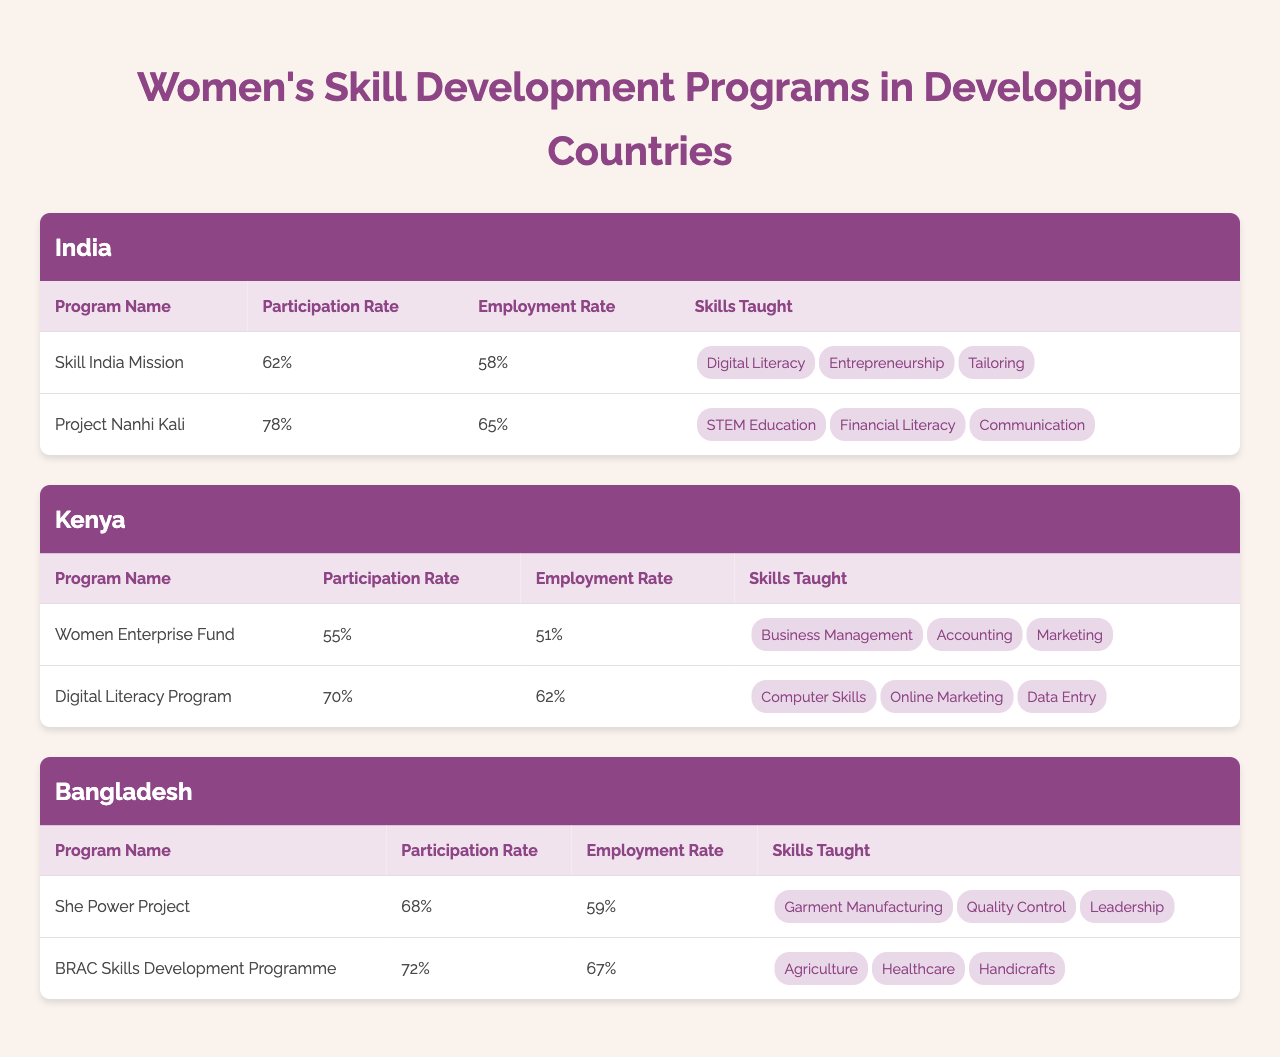What is the participation rate for the "She Power Project" in Bangladesh? The table indicates that the participation rate for the "She Power Project" in Bangladesh is listed under its respective section, which shows "68%".
Answer: 68% Which country has the highest employment rate among the programs listed? To find the highest employment rate, I compare the employment rates across all programs: India's "Project Nanhi Kali" is 65%, Bangladesh's "BRAC Skills Development Programme" is 67%, and Kenya's highest is 62%. The highest is from Bangladesh.
Answer: Bangladesh Which skills are taught in the "Digital Literacy Program" in Kenya? The table presents the skills taught under each program. For the "Digital Literacy Program", the skills listed are "Computer Skills," "Online Marketing," and "Data Entry."
Answer: Computer Skills, Online Marketing, Data Entry Calculate the average participation rate for programs in India. The participation rates for India's programs are 62% and 78%. I add these rates together (62 + 78 = 140) and divide by 2 (140/2 = 70) to find the average.
Answer: 70% Is the employment rate for the "Women Enterprise Fund" in Kenya greater than 50%? Looking at the table, the employment rate for the "Women Enterprise Fund" is 51%, which is indeed greater than 50%.
Answer: Yes Which program has the lowest participation rate, and what is that rate? The lowest participation rate can be found by examining each program's participation rate. The "Women Enterprise Fund" in Kenya has the lowest participation at 55%.
Answer: 55% What is the difference in employment rates between the "Skill India Mission" in India and the "She Power Project" in Bangladesh? The employment rate for the "Skill India Mission" is 58%, while for the "She Power Project," it is 59%. The difference is calculated by subtracting 58 from 59, which equals 1.
Answer: 1% How many unique skills are taught across all programs in India? The "Skill India Mission" teaches three skills, and "Project Nanhi Kali" teaches three different skills. Therefore, the unique skills must be counted: Digital Literacy, Entrepreneurship, Tailoring from the first program, and STEM Education, Financial Literacy, Communication from the second program. The unique skills are 6 in total.
Answer: 6 Which country's programs have an average employment rate above 60%? First, I calculate the average employment rate for each country. For India, it is (58 + 65)/2 = 61.5%. For Kenya, it's (51 + 62)/2 = 56.5%. For Bangladesh, it's (59 + 67)/2 = 63%. Only Bangladesh exceeds 60%.
Answer: Bangladesh Are there any programs listed that do not teach "Leadership" as a skill? By reviewing the skills taught in each program, "Leadership" is taught in the "She Power Project" from Bangladesh; however, it is not included in any other program, meaning there are programs without "Leadership".
Answer: Yes 